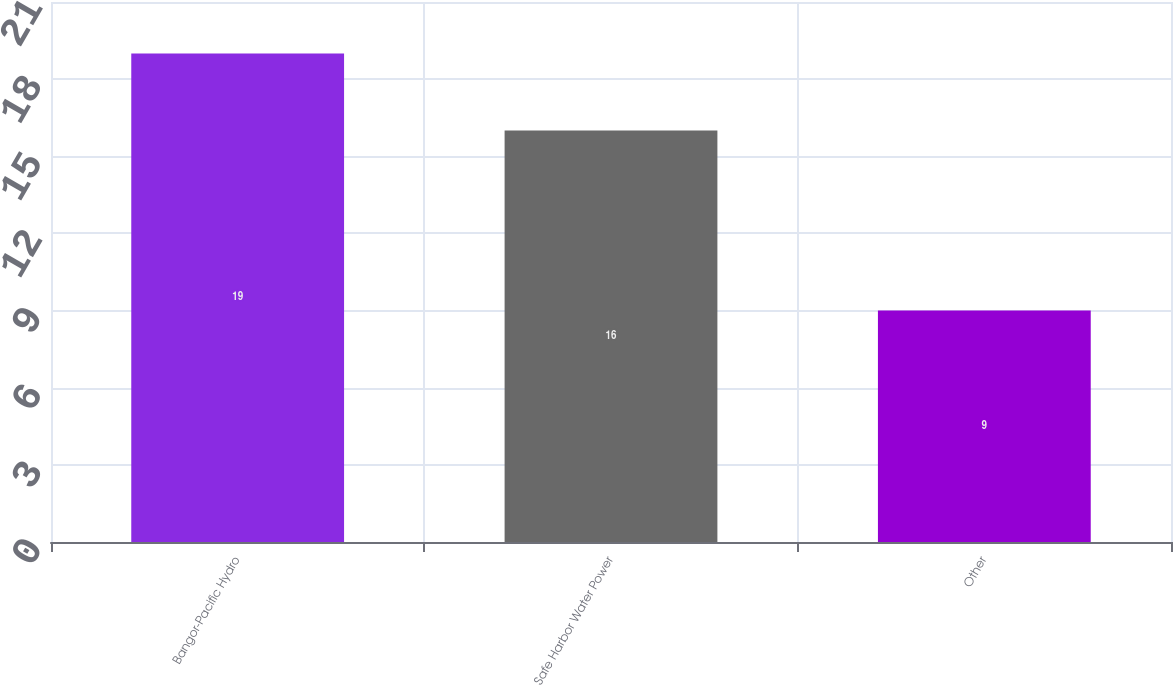Convert chart. <chart><loc_0><loc_0><loc_500><loc_500><bar_chart><fcel>Bangor-Pacific Hydro<fcel>Safe Harbor Water Power<fcel>Other<nl><fcel>19<fcel>16<fcel>9<nl></chart> 